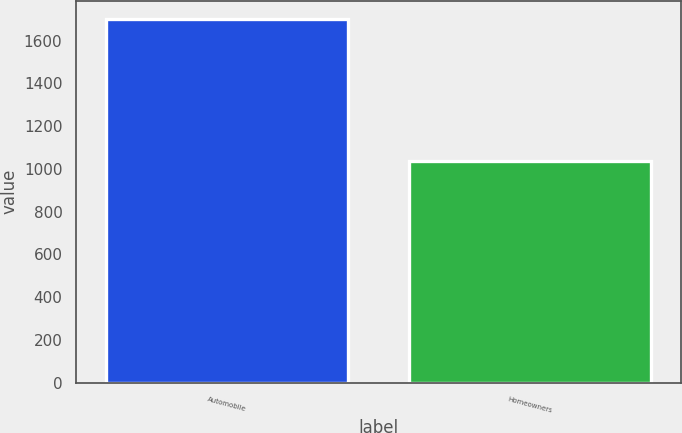Convert chart. <chart><loc_0><loc_0><loc_500><loc_500><bar_chart><fcel>Automobile<fcel>Homeowners<nl><fcel>1702<fcel>1038<nl></chart> 